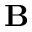<formula> <loc_0><loc_0><loc_500><loc_500>B</formula> 